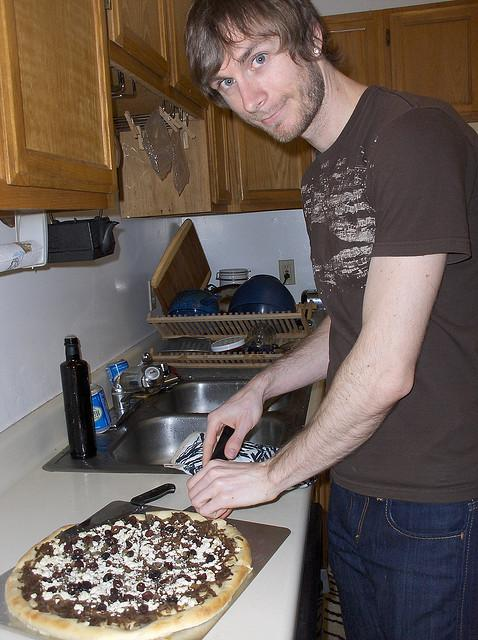What company is known for making the item that is on the counter? Please explain your reasoning. domino's. The company is domino's. 